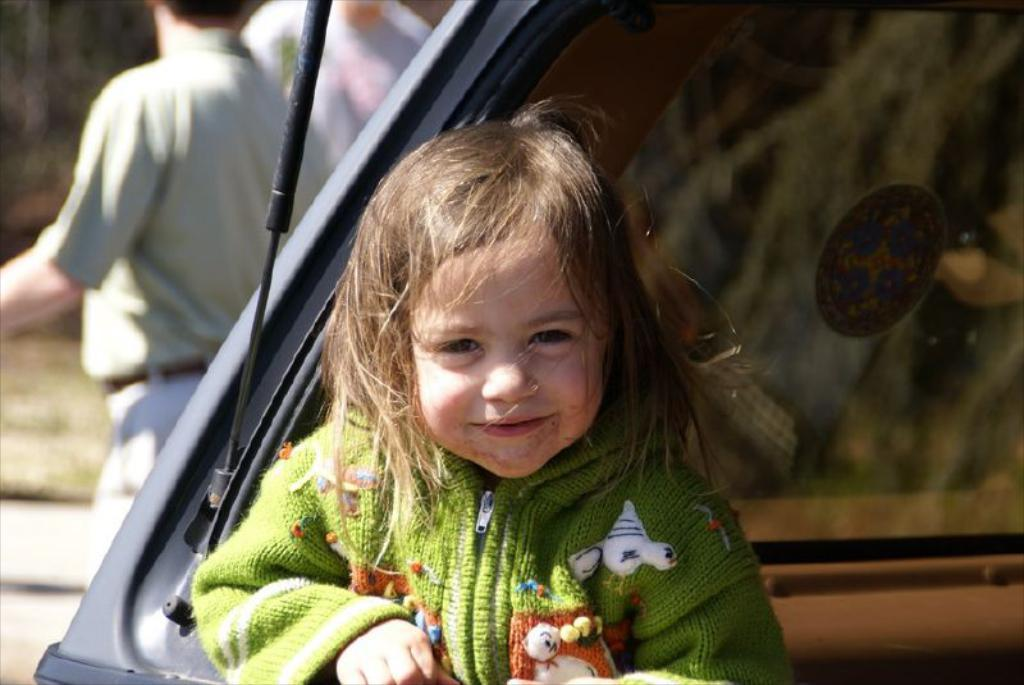Who is present in the image? There is a kid in the image. What is the kid doing in the image? The kid is smiling. What can be seen on the right side of the image? There is a glass on the right side of the image. Can you describe the background of the image? The background of the image is blurry, and there is another person present. What type of pipe can be seen in the image? There is no pipe present in the image. How many cattle are visible in the image? There are no cattle present in the image. 